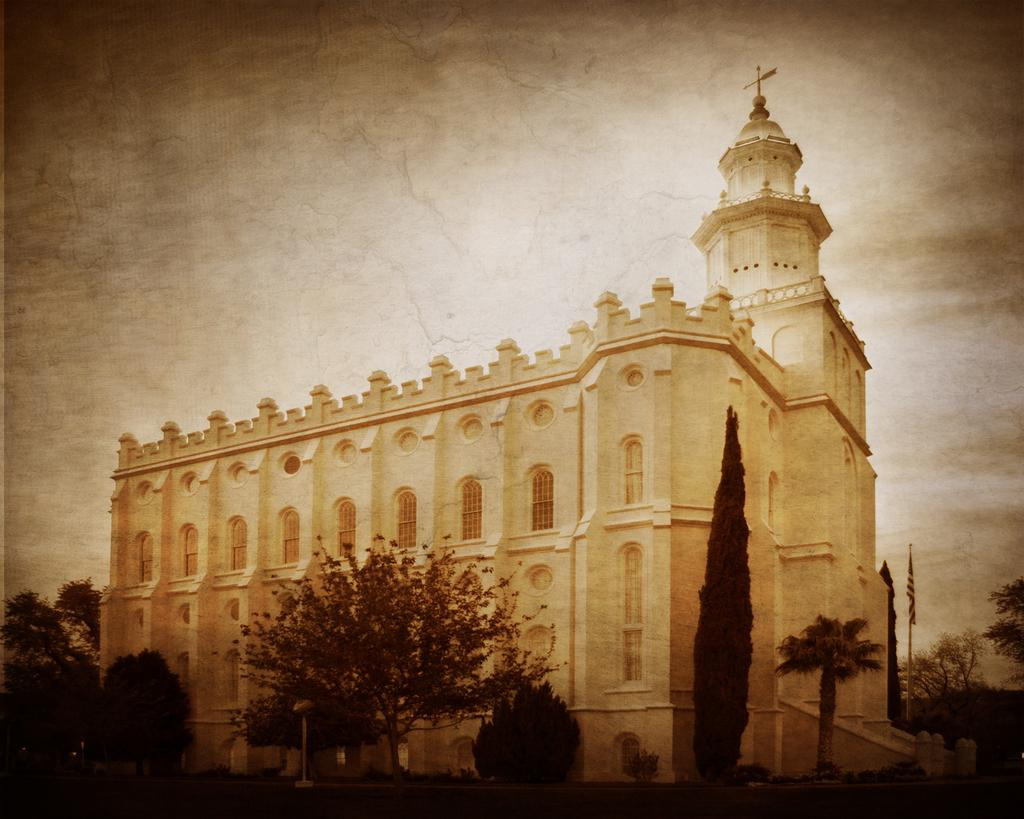What type of structure is present in the image? There is a building in the image. What other natural elements can be seen in the image? There is a group of trees in the image. What are the poles used for in the image? The poles are likely used for supporting the flag in the image. What is the background of the image? The sky is visible in the background of the image. Can you see any bees or bait in the image? No, there are no bees or bait present in the image. Is there a pet visible in the image? No, there is no pet visible in the image. 